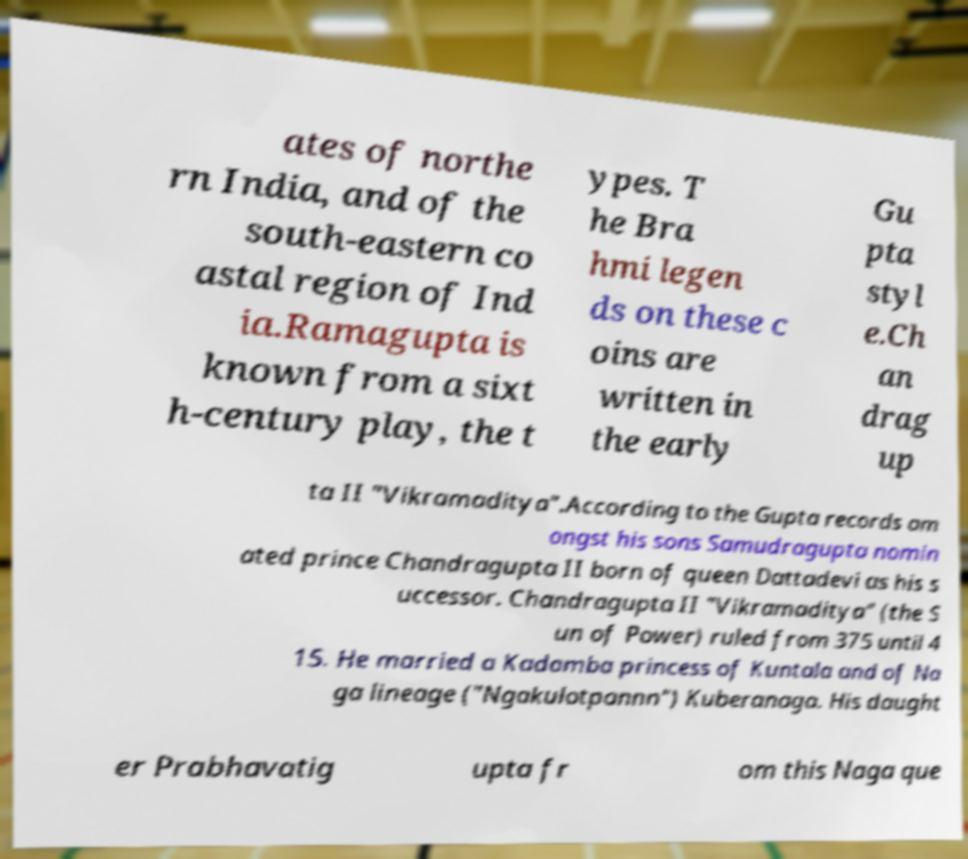What messages or text are displayed in this image? I need them in a readable, typed format. ates of northe rn India, and of the south-eastern co astal region of Ind ia.Ramagupta is known from a sixt h-century play, the t ypes. T he Bra hmi legen ds on these c oins are written in the early Gu pta styl e.Ch an drag up ta II "Vikramaditya".According to the Gupta records am ongst his sons Samudragupta nomin ated prince Chandragupta II born of queen Dattadevi as his s uccessor. Chandragupta II "Vikramaditya" (the S un of Power) ruled from 375 until 4 15. He married a Kadamba princess of Kuntala and of Na ga lineage ("Ngakulotpannn") Kuberanaga. His daught er Prabhavatig upta fr om this Naga que 